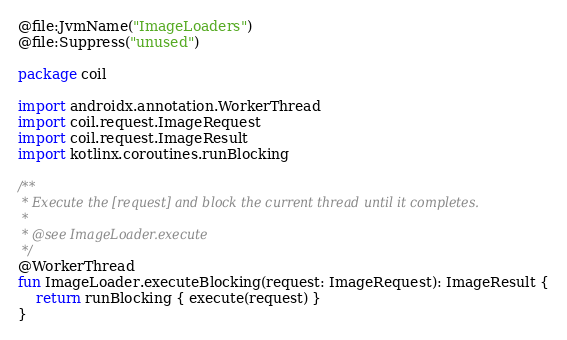<code> <loc_0><loc_0><loc_500><loc_500><_Kotlin_>@file:JvmName("ImageLoaders")
@file:Suppress("unused")

package coil

import androidx.annotation.WorkerThread
import coil.request.ImageRequest
import coil.request.ImageResult
import kotlinx.coroutines.runBlocking

/**
 * Execute the [request] and block the current thread until it completes.
 *
 * @see ImageLoader.execute
 */
@WorkerThread
fun ImageLoader.executeBlocking(request: ImageRequest): ImageResult {
    return runBlocking { execute(request) }
}
</code> 